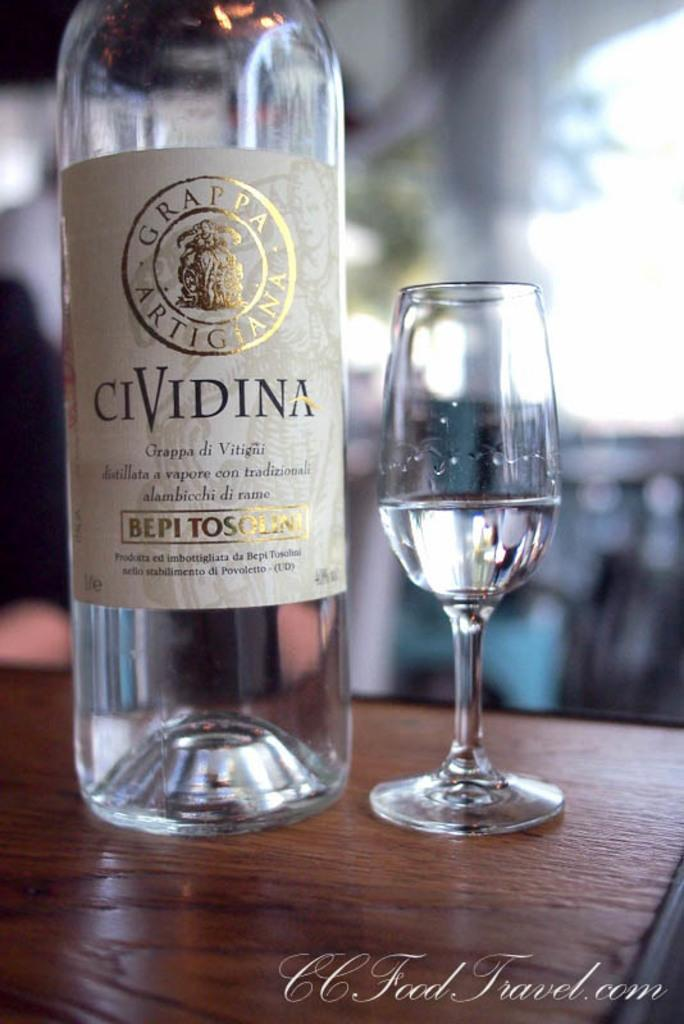What is the empty container in the image? There is an empty bottle in the image. What is the full container in the image? There is a glass of wine in the image. Where are the bottle and glass located? Both the bottle and the glass are on a table. What can be seen in the background of the image? There is a window visible in the background of the image. What month is it in the image? The month cannot be determined from the image, as there is no information about the date or time of year. Is there a basketball game happening in the image? There is no basketball game or any reference to sports in the image. 